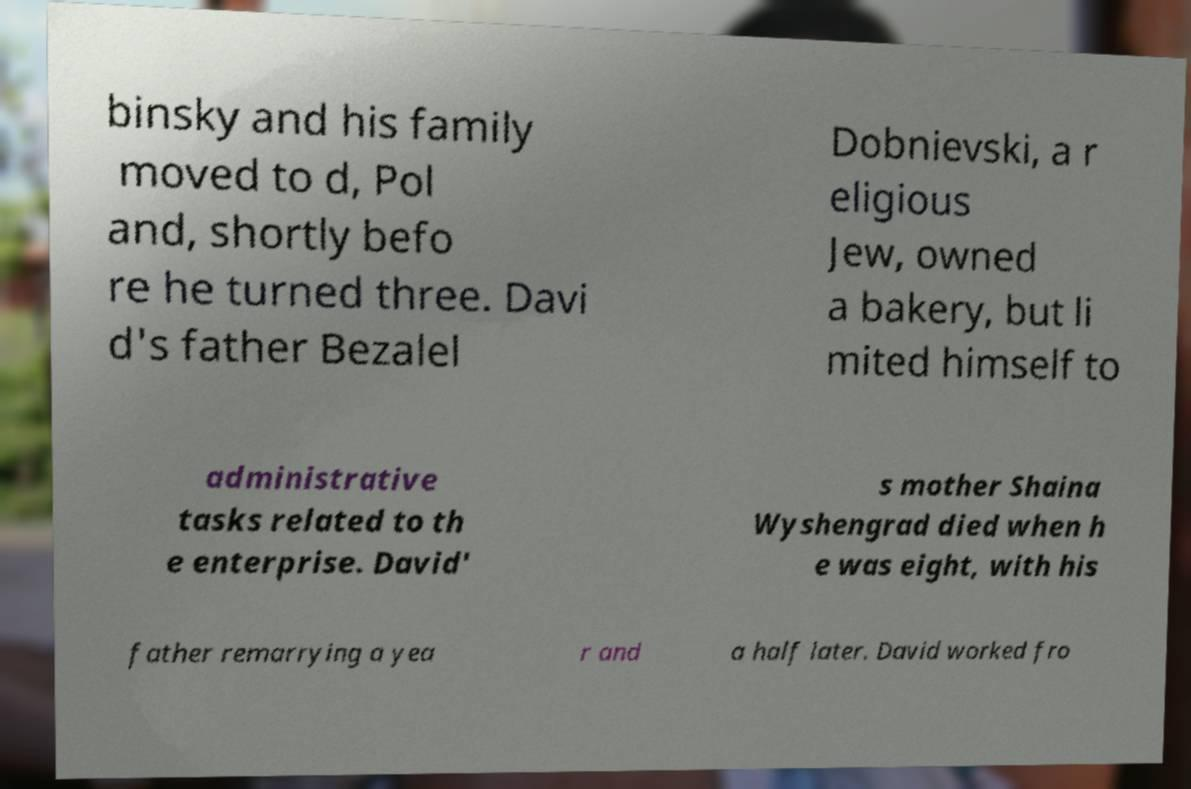Please identify and transcribe the text found in this image. binsky and his family moved to d, Pol and, shortly befo re he turned three. Davi d's father Bezalel Dobnievski, a r eligious Jew, owned a bakery, but li mited himself to administrative tasks related to th e enterprise. David' s mother Shaina Wyshengrad died when h e was eight, with his father remarrying a yea r and a half later. David worked fro 